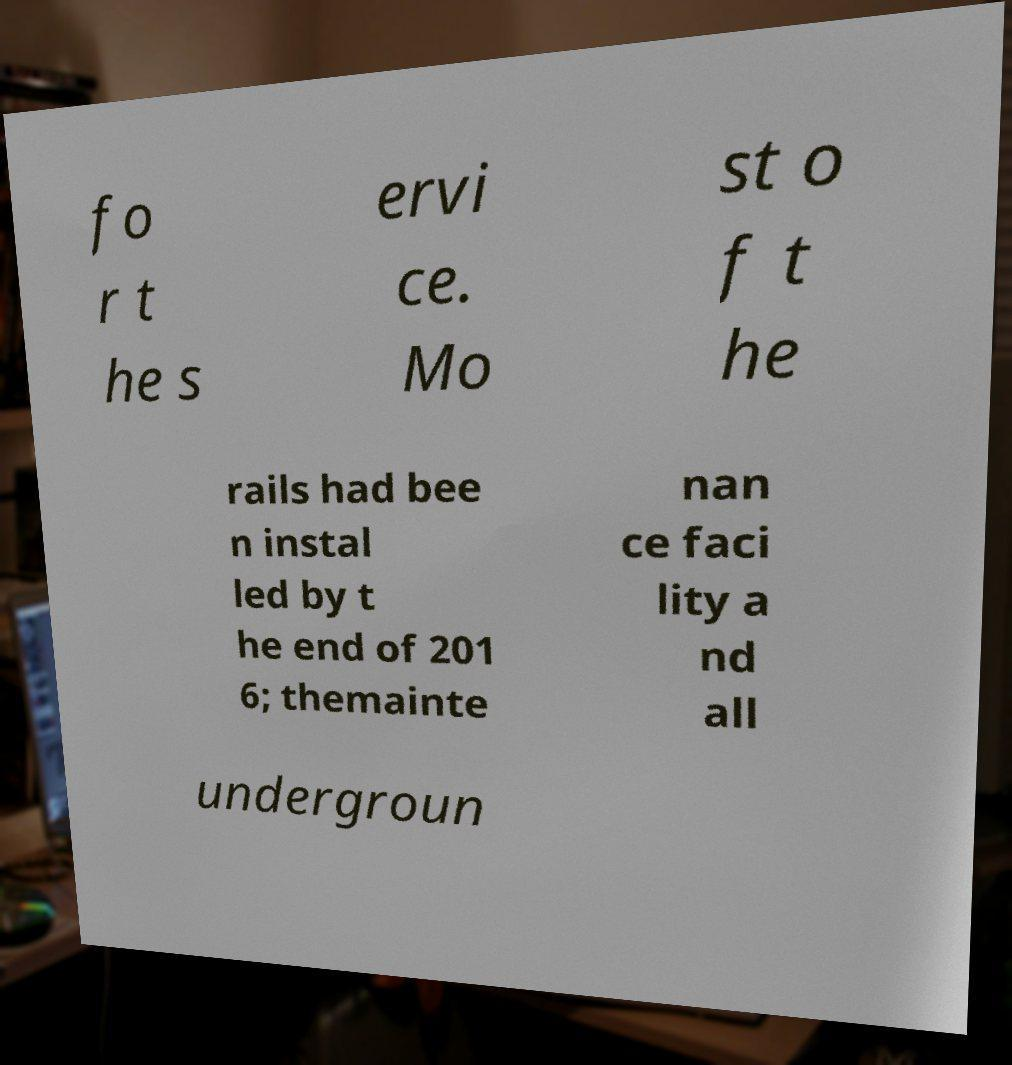Could you extract and type out the text from this image? fo r t he s ervi ce. Mo st o f t he rails had bee n instal led by t he end of 201 6; themainte nan ce faci lity a nd all undergroun 